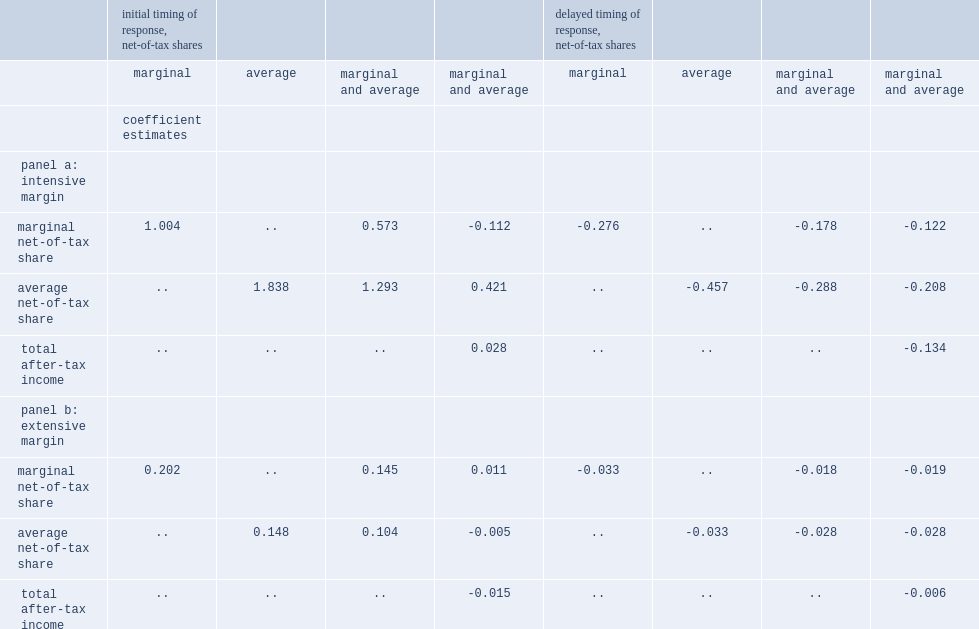For each 1% increase in the average net-of-tax share, what is estimated increase of labour income in the preferred model specification? 0.421. 